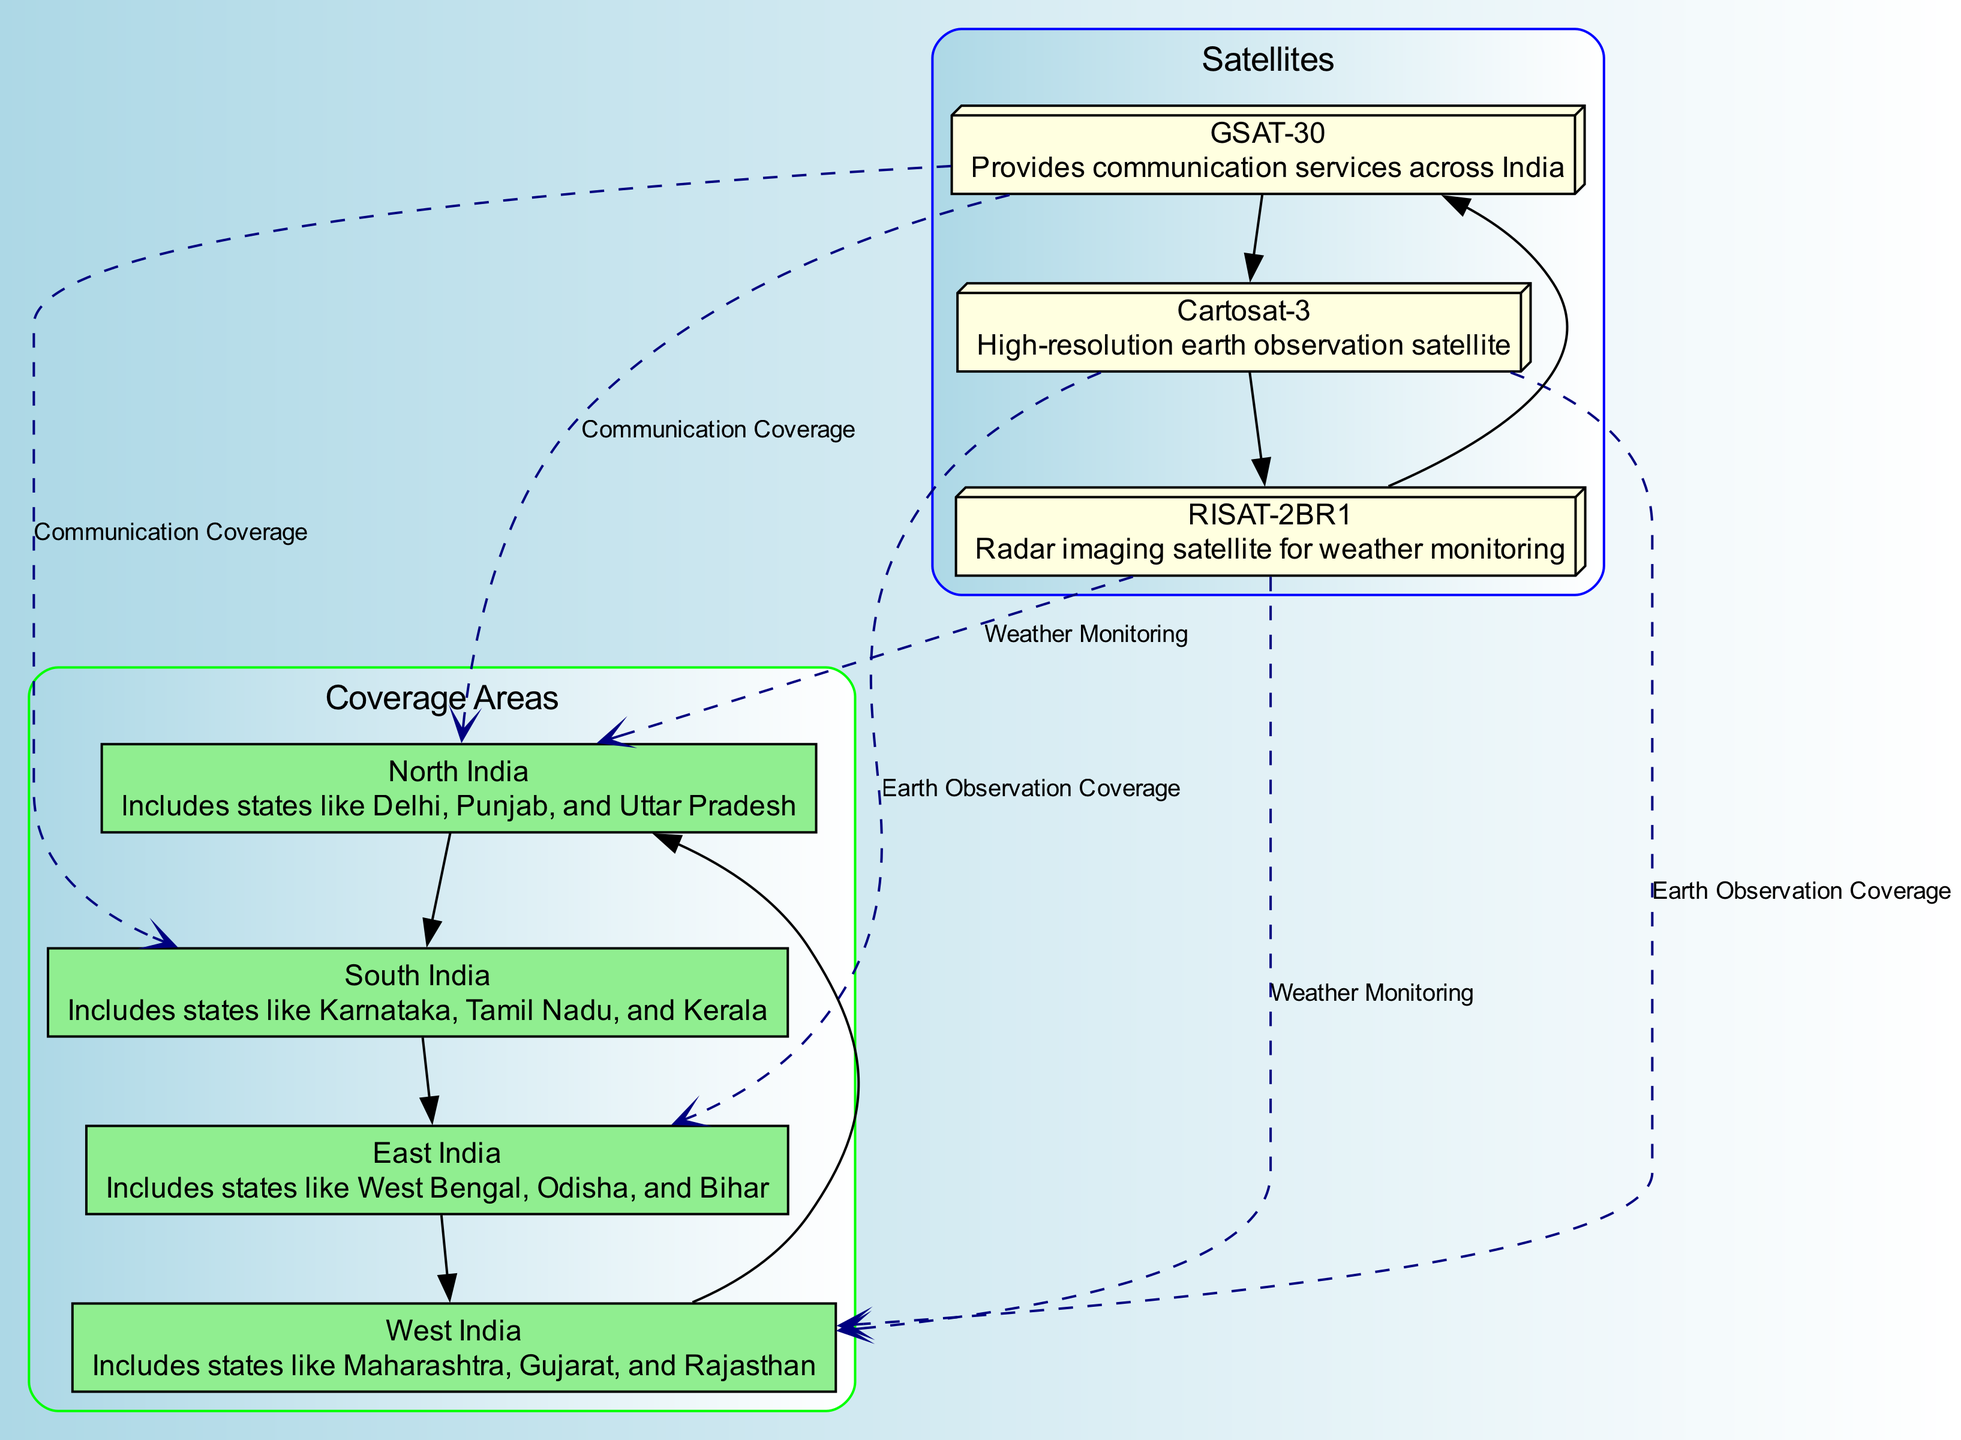What is the label of the first satellite? The first satellite listed in the nodes is identified as "Sat1", and its label is "GSAT-30".
Answer: GSAT-30 How many coverage areas are represented in the diagram? There are four coverage areas listed in the nodes: North India, South India, East India, and West India.
Answer: Four What type of coverage does GSAT-30 provide to South India? GSAT-30 provides "Communication Coverage" to South India as indicated by the corresponding edge.
Answer: Communication Coverage Which satellite is responsible for weather monitoring in North India? The satellite labeled "RISAT-2BR1" is connected to North India with an edge that indicates its function as a weather monitoring satellite.
Answer: RISAT-2BR1 Which coverage area does Cartosat-3 provide Earth observation coverage to? Cartosat-3 provides Earth observation coverage to East India and West India as outlined in the edges connecting the satellite to these areas.
Answer: East India and West India How many satellites are mentioned in the diagram? The diagram mentions three satellites: GSAT-30, Cartosat-3, and RISAT-2BR1, as listed in the nodes section.
Answer: Three Which two satellites have a direct edge connecting them? According to the diagram's edges, GSAT-30 and RISAT-2BR1 are directly connected as they provide relationships to respective coverage areas.
Answer: GSAT-30 and RISAT-2BR1 What is the primary function of Cartosat-3? The primary function of Cartosat-3, as noted in its description, is "High-resolution earth observation".
Answer: High-resolution earth observation To which coverage area does RISAT-2BR1 provide coverage according to the diagram? RISAT-2BR1 provides coverage related to "Weather Monitoring" for North India, highlighted in the corresponding edge.
Answer: North India 